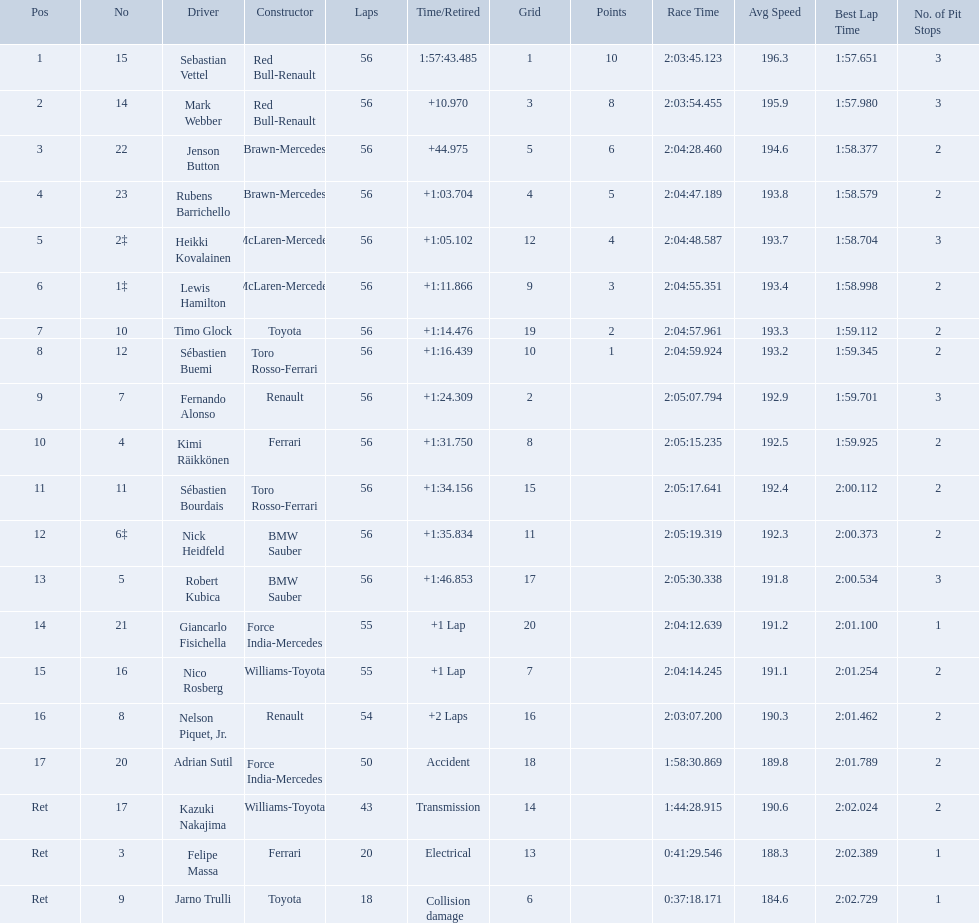Who are all of the drivers? Sebastian Vettel, Mark Webber, Jenson Button, Rubens Barrichello, Heikki Kovalainen, Lewis Hamilton, Timo Glock, Sébastien Buemi, Fernando Alonso, Kimi Räikkönen, Sébastien Bourdais, Nick Heidfeld, Robert Kubica, Giancarlo Fisichella, Nico Rosberg, Nelson Piquet, Jr., Adrian Sutil, Kazuki Nakajima, Felipe Massa, Jarno Trulli. Who were their constructors? Red Bull-Renault, Red Bull-Renault, Brawn-Mercedes, Brawn-Mercedes, McLaren-Mercedes, McLaren-Mercedes, Toyota, Toro Rosso-Ferrari, Renault, Ferrari, Toro Rosso-Ferrari, BMW Sauber, BMW Sauber, Force India-Mercedes, Williams-Toyota, Renault, Force India-Mercedes, Williams-Toyota, Ferrari, Toyota. Who was the first listed driver to not drive a ferrari?? Sebastian Vettel. Which drivers took part in the 2009 chinese grand prix? Sebastian Vettel, Mark Webber, Jenson Button, Rubens Barrichello, Heikki Kovalainen, Lewis Hamilton, Timo Glock, Sébastien Buemi, Fernando Alonso, Kimi Räikkönen, Sébastien Bourdais, Nick Heidfeld, Robert Kubica, Giancarlo Fisichella, Nico Rosberg, Nelson Piquet, Jr., Adrian Sutil, Kazuki Nakajima, Felipe Massa, Jarno Trulli. Of these, who completed all 56 laps? Sebastian Vettel, Mark Webber, Jenson Button, Rubens Barrichello, Heikki Kovalainen, Lewis Hamilton, Timo Glock, Sébastien Buemi, Fernando Alonso, Kimi Räikkönen, Sébastien Bourdais, Nick Heidfeld, Robert Kubica. Can you parse all the data within this table? {'header': ['Pos', 'No', 'Driver', 'Constructor', 'Laps', 'Time/Retired', 'Grid', 'Points', 'Race Time', 'Avg Speed', 'Best Lap Time', 'No. of Pit Stops'], 'rows': [['1', '15', 'Sebastian Vettel', 'Red Bull-Renault', '56', '1:57:43.485', '1', '10', '2:03:45.123', '196.3', '1:57.651', '3'], ['2', '14', 'Mark Webber', 'Red Bull-Renault', '56', '+10.970', '3', '8', '2:03:54.455', '195.9', '1:57.980', '3'], ['3', '22', 'Jenson Button', 'Brawn-Mercedes', '56', '+44.975', '5', '6', '2:04:28.460', '194.6', '1:58.377', '2'], ['4', '23', 'Rubens Barrichello', 'Brawn-Mercedes', '56', '+1:03.704', '4', '5', '2:04:47.189', '193.8', '1:58.579', '2'], ['5', '2‡', 'Heikki Kovalainen', 'McLaren-Mercedes', '56', '+1:05.102', '12', '4', '2:04:48.587', '193.7', '1:58.704', '3'], ['6', '1‡', 'Lewis Hamilton', 'McLaren-Mercedes', '56', '+1:11.866', '9', '3', '2:04:55.351', '193.4', '1:58.998', '2'], ['7', '10', 'Timo Glock', 'Toyota', '56', '+1:14.476', '19', '2', '2:04:57.961', '193.3', '1:59.112', '2'], ['8', '12', 'Sébastien Buemi', 'Toro Rosso-Ferrari', '56', '+1:16.439', '10', '1', '2:04:59.924', '193.2', '1:59.345', '2'], ['9', '7', 'Fernando Alonso', 'Renault', '56', '+1:24.309', '2', '', '2:05:07.794', '192.9', '1:59.701', '3'], ['10', '4', 'Kimi Räikkönen', 'Ferrari', '56', '+1:31.750', '8', '', '2:05:15.235', '192.5', '1:59.925', '2'], ['11', '11', 'Sébastien Bourdais', 'Toro Rosso-Ferrari', '56', '+1:34.156', '15', '', '2:05:17.641', '192.4', '2:00.112', '2'], ['12', '6‡', 'Nick Heidfeld', 'BMW Sauber', '56', '+1:35.834', '11', '', '2:05:19.319', '192.3', '2:00.373', '2'], ['13', '5', 'Robert Kubica', 'BMW Sauber', '56', '+1:46.853', '17', '', '2:05:30.338', '191.8', '2:00.534', '3'], ['14', '21', 'Giancarlo Fisichella', 'Force India-Mercedes', '55', '+1 Lap', '20', '', '2:04:12.639', '191.2', '2:01.100', '1'], ['15', '16', 'Nico Rosberg', 'Williams-Toyota', '55', '+1 Lap', '7', '', '2:04:14.245', '191.1', '2:01.254', '2'], ['16', '8', 'Nelson Piquet, Jr.', 'Renault', '54', '+2 Laps', '16', '', '2:03:07.200', '190.3', '2:01.462', '2'], ['17', '20', 'Adrian Sutil', 'Force India-Mercedes', '50', 'Accident', '18', '', '1:58:30.869', '189.8', '2:01.789', '2'], ['Ret', '17', 'Kazuki Nakajima', 'Williams-Toyota', '43', 'Transmission', '14', '', '1:44:28.915', '190.6', '2:02.024', '2'], ['Ret', '3', 'Felipe Massa', 'Ferrari', '20', 'Electrical', '13', '', '0:41:29.546', '188.3', '2:02.389', '1'], ['Ret', '9', 'Jarno Trulli', 'Toyota', '18', 'Collision damage', '6', '', '0:37:18.171', '184.6', '2:02.729', '1']]} Of these, which did ferrari not participate as a constructor? Sebastian Vettel, Mark Webber, Jenson Button, Rubens Barrichello, Heikki Kovalainen, Lewis Hamilton, Timo Glock, Fernando Alonso, Kimi Räikkönen, Nick Heidfeld, Robert Kubica. Of the remaining, which is in pos 1? Sebastian Vettel. Which drivers raced in the 2009 chinese grand prix? Sebastian Vettel, Mark Webber, Jenson Button, Rubens Barrichello, Heikki Kovalainen, Lewis Hamilton, Timo Glock, Sébastien Buemi, Fernando Alonso, Kimi Räikkönen, Sébastien Bourdais, Nick Heidfeld, Robert Kubica, Giancarlo Fisichella, Nico Rosberg, Nelson Piquet, Jr., Adrian Sutil, Kazuki Nakajima, Felipe Massa, Jarno Trulli. Of the drivers in the 2009 chinese grand prix, which finished the race? Sebastian Vettel, Mark Webber, Jenson Button, Rubens Barrichello, Heikki Kovalainen, Lewis Hamilton, Timo Glock, Sébastien Buemi, Fernando Alonso, Kimi Räikkönen, Sébastien Bourdais, Nick Heidfeld, Robert Kubica. Of the drivers who finished the race, who had the slowest time? Robert Kubica. Who were the drivers at the 2009 chinese grand prix? Sebastian Vettel, Mark Webber, Jenson Button, Rubens Barrichello, Heikki Kovalainen, Lewis Hamilton, Timo Glock, Sébastien Buemi, Fernando Alonso, Kimi Räikkönen, Sébastien Bourdais, Nick Heidfeld, Robert Kubica, Giancarlo Fisichella, Nico Rosberg, Nelson Piquet, Jr., Adrian Sutil, Kazuki Nakajima, Felipe Massa, Jarno Trulli. Who had the slowest time? Robert Kubica. Who were all of the drivers in the 2009 chinese grand prix? Sebastian Vettel, Mark Webber, Jenson Button, Rubens Barrichello, Heikki Kovalainen, Lewis Hamilton, Timo Glock, Sébastien Buemi, Fernando Alonso, Kimi Räikkönen, Sébastien Bourdais, Nick Heidfeld, Robert Kubica, Giancarlo Fisichella, Nico Rosberg, Nelson Piquet, Jr., Adrian Sutil, Kazuki Nakajima, Felipe Massa, Jarno Trulli. And what were their finishing times? 1:57:43.485, +10.970, +44.975, +1:03.704, +1:05.102, +1:11.866, +1:14.476, +1:16.439, +1:24.309, +1:31.750, +1:34.156, +1:35.834, +1:46.853, +1 Lap, +1 Lap, +2 Laps, Accident, Transmission, Electrical, Collision damage. Which player faced collision damage and retired from the race? Jarno Trulli. 